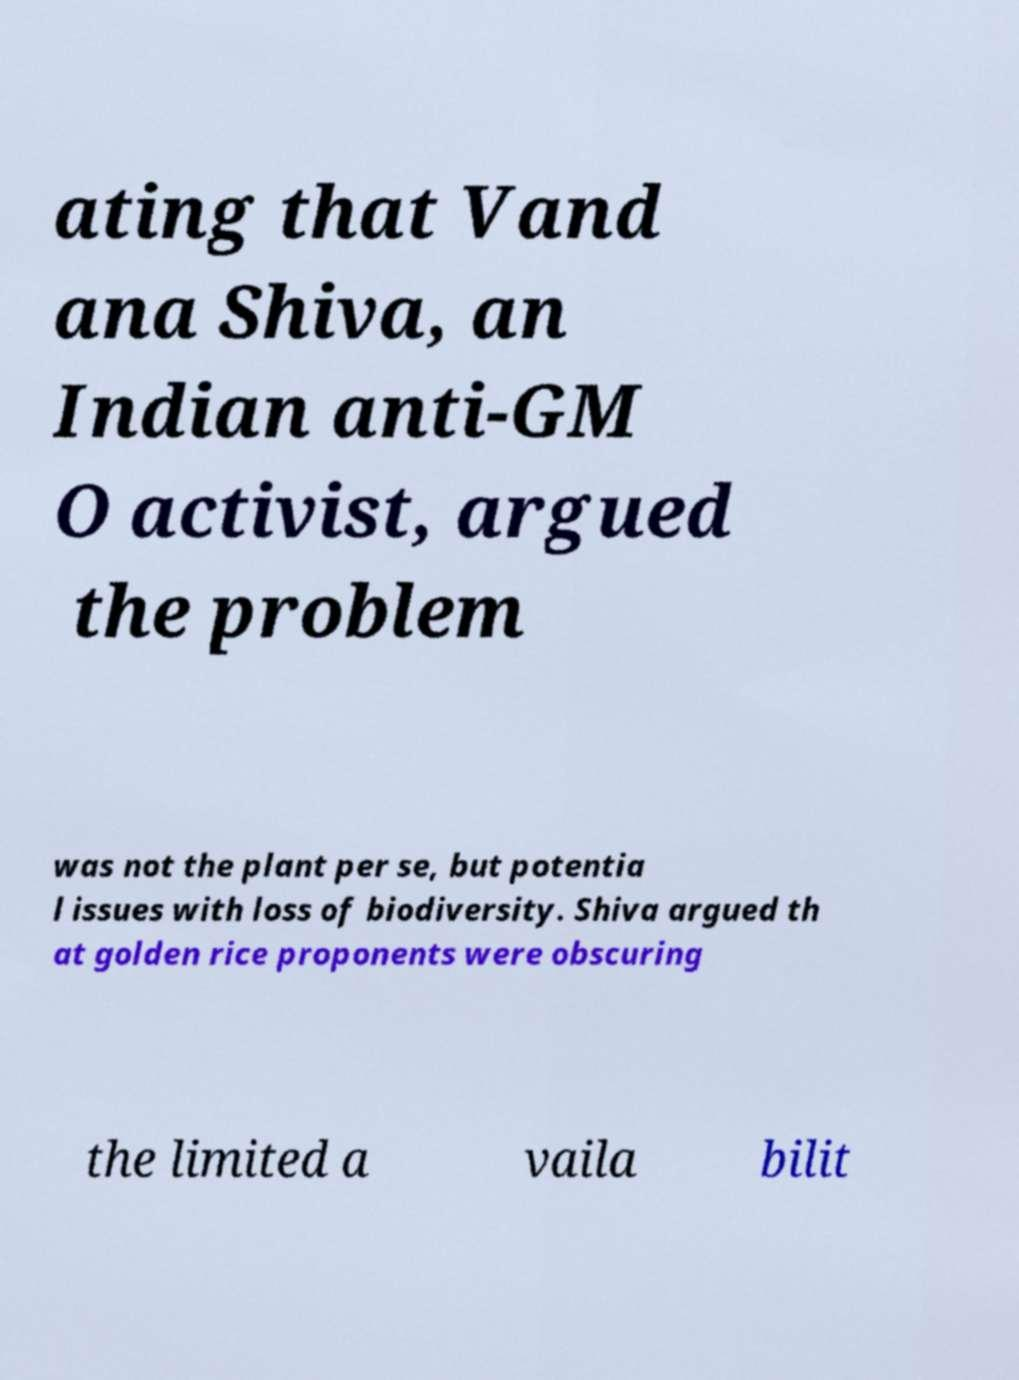Could you assist in decoding the text presented in this image and type it out clearly? ating that Vand ana Shiva, an Indian anti-GM O activist, argued the problem was not the plant per se, but potentia l issues with loss of biodiversity. Shiva argued th at golden rice proponents were obscuring the limited a vaila bilit 